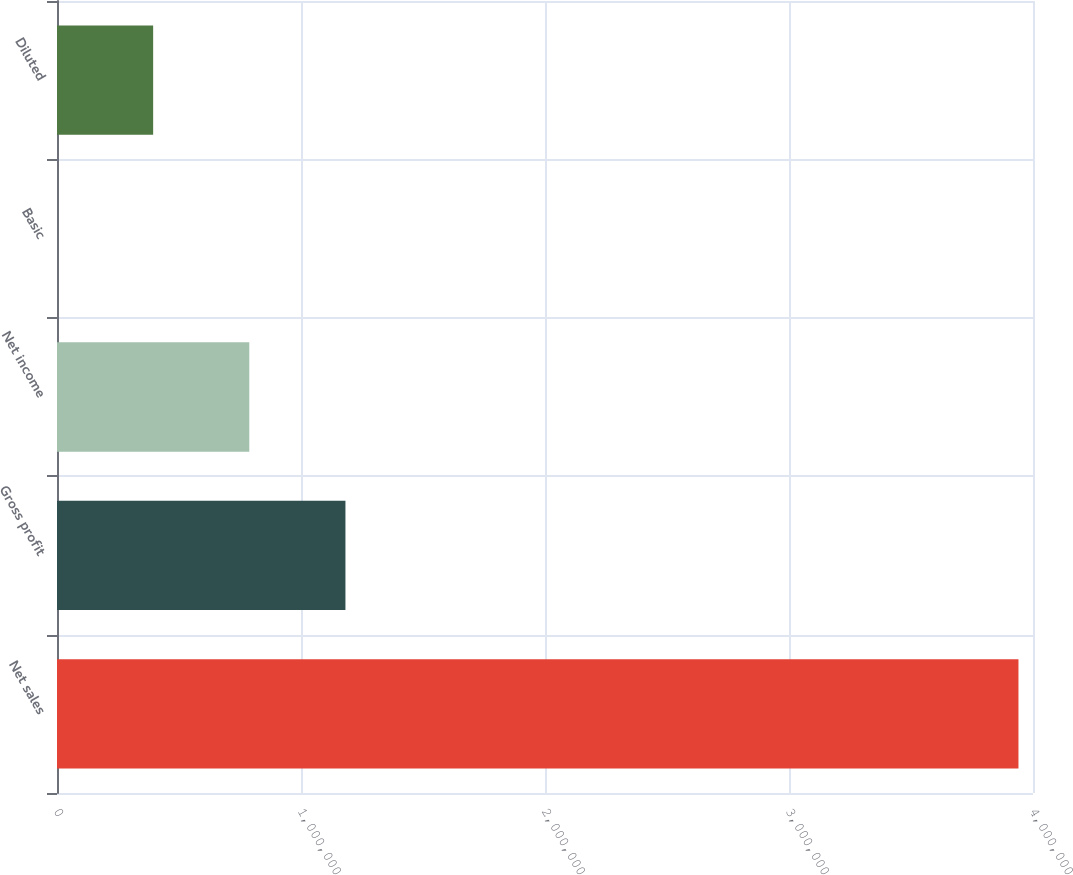Convert chart to OTSL. <chart><loc_0><loc_0><loc_500><loc_500><bar_chart><fcel>Net sales<fcel>Gross profit<fcel>Net income<fcel>Basic<fcel>Diluted<nl><fcel>3.9404e+06<fcel>1.18212e+06<fcel>788081<fcel>1.28<fcel>394041<nl></chart> 